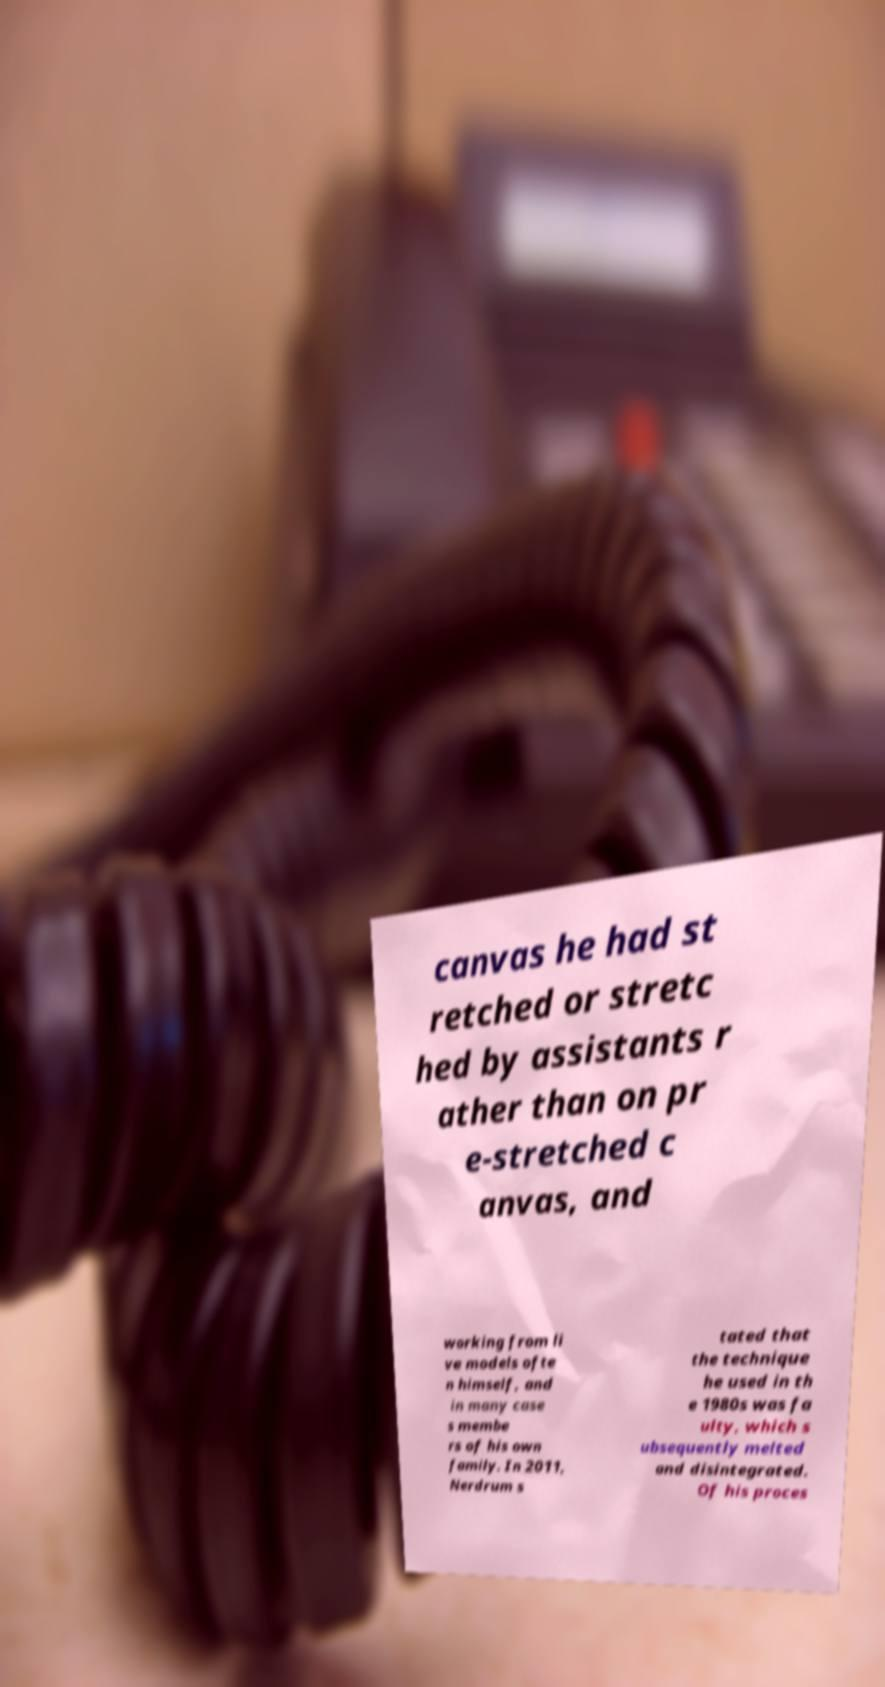Please read and relay the text visible in this image. What does it say? canvas he had st retched or stretc hed by assistants r ather than on pr e-stretched c anvas, and working from li ve models ofte n himself, and in many case s membe rs of his own family. In 2011, Nerdrum s tated that the technique he used in th e 1980s was fa ulty, which s ubsequently melted and disintegrated. Of his proces 